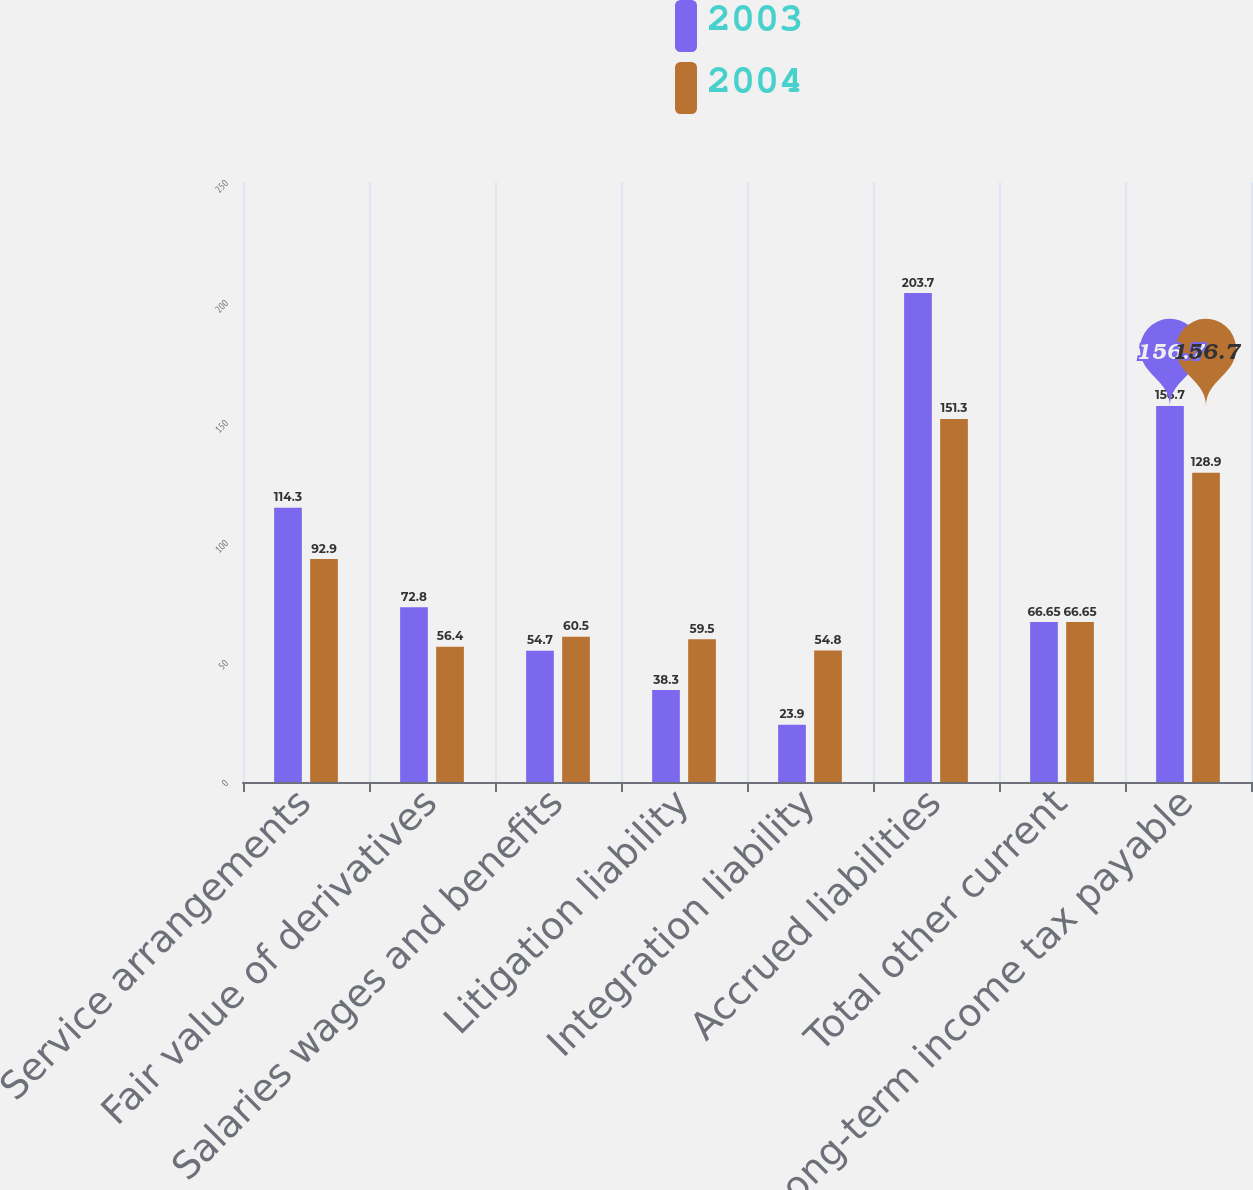<chart> <loc_0><loc_0><loc_500><loc_500><stacked_bar_chart><ecel><fcel>Service arrangements<fcel>Fair value of derivatives<fcel>Salaries wages and benefits<fcel>Litigation liability<fcel>Integration liability<fcel>Accrued liabilities<fcel>Total other current<fcel>Long-term income tax payable<nl><fcel>2003<fcel>114.3<fcel>72.8<fcel>54.7<fcel>38.3<fcel>23.9<fcel>203.7<fcel>66.65<fcel>156.7<nl><fcel>2004<fcel>92.9<fcel>56.4<fcel>60.5<fcel>59.5<fcel>54.8<fcel>151.3<fcel>66.65<fcel>128.9<nl></chart> 